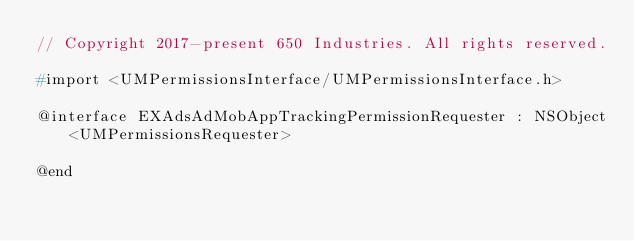<code> <loc_0><loc_0><loc_500><loc_500><_C_>// Copyright 2017-present 650 Industries. All rights reserved.

#import <UMPermissionsInterface/UMPermissionsInterface.h>

@interface EXAdsAdMobAppTrackingPermissionRequester : NSObject<UMPermissionsRequester>

@end
</code> 